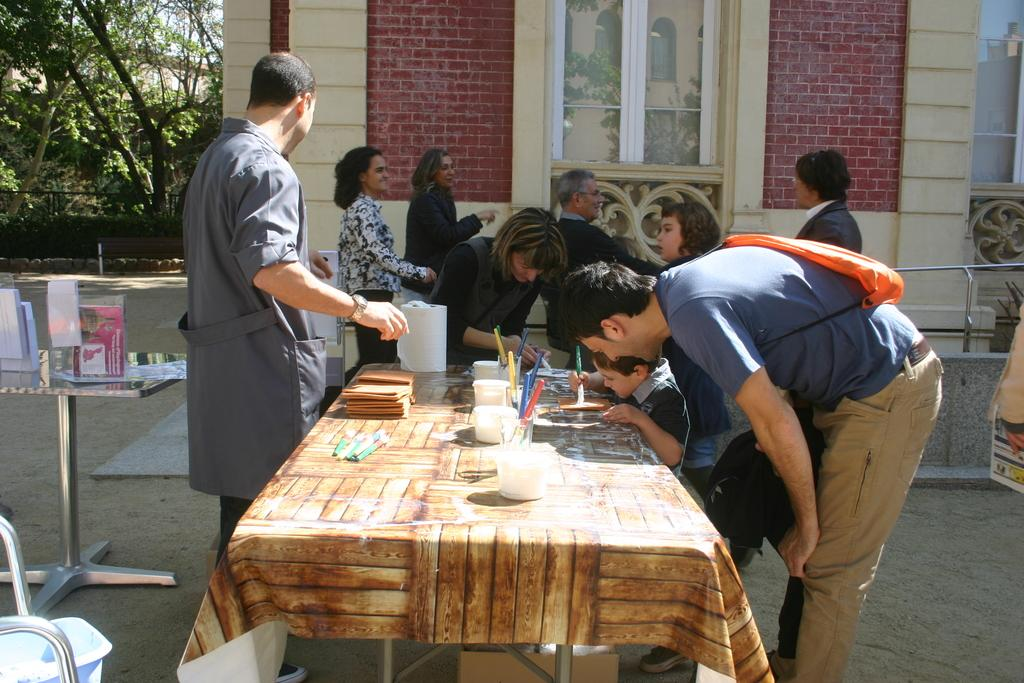Who or what can be seen in the image? There are people in the image. What objects are present on the tables in the image? There are bowls, pens, and papers on the tables in the image. Can you describe the background of the image? There are trees and a house in the background of the image. What type of lace can be seen on the government building in the image? There is no government building or lace present in the image. How does the dock look like in the image? There is no dock present in the image. 